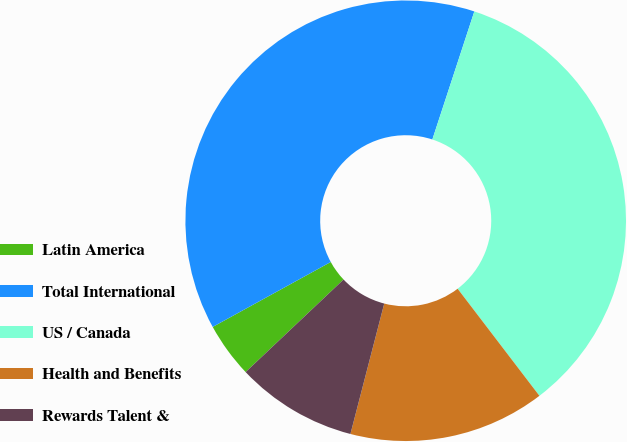Convert chart to OTSL. <chart><loc_0><loc_0><loc_500><loc_500><pie_chart><fcel>Latin America<fcel>Total International<fcel>US / Canada<fcel>Health and Benefits<fcel>Rewards Talent &<nl><fcel>4.05%<fcel>38.05%<fcel>34.58%<fcel>14.42%<fcel>8.91%<nl></chart> 